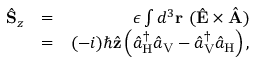<formula> <loc_0><loc_0><loc_500><loc_500>\begin{array} { r l r } { \hat { S } _ { z } } & { = } & { \epsilon \int d ^ { 3 } { r } \ ( \hat { E } \times \hat { A } ) } \\ & { = } & { ( - i ) \hbar { \hat } { z } \left ( \hat { a } _ { H } ^ { \dagger } \hat { a } _ { V } - \hat { a } _ { V } ^ { \dagger } \hat { a } _ { H } \right ) , } \end{array}</formula> 